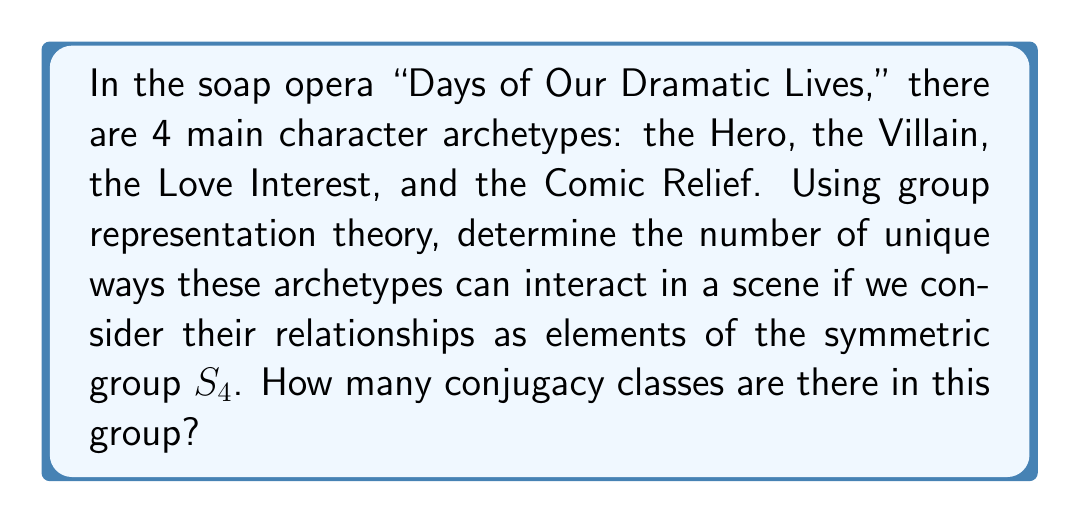Give your solution to this math problem. Let's break this down step-by-step:

1) First, we need to understand what the symmetric group $S_4$ represents in this context. $S_4$ is the group of all permutations of 4 elements, which in our case are the 4 character archetypes.

2) In group theory, conjugacy classes are sets of elements that are related by conjugation. Two elements $a$ and $b$ are conjugate if there exists an element $g$ in the group such that $gag^{-1} = b$.

3) For $S_4$, the conjugacy classes are determined by the cycle structure of the permutations. Let's list out the possible cycle structures:

   - Identity: (1)
   - 2-cycles: (2)
   - 3-cycles: (3)
   - 4-cycles: (4)
   - Product of two 2-cycles: (2)(2)

4) Each of these cycle structures represents a different way the character archetypes can interact:
   - (1): No change in dynamics
   - (2): Two characters swap roles
   - (3): Three characters rotate roles
   - (4): All four characters rotate roles
   - (2)(2): Two pairs of characters swap roles

5) The number of conjugacy classes is equal to the number of these distinct cycle structures.

Therefore, there are 5 conjugacy classes in $S_4$, representing 5 unique ways the soap opera archetypes can interact in a scene.
Answer: 5 